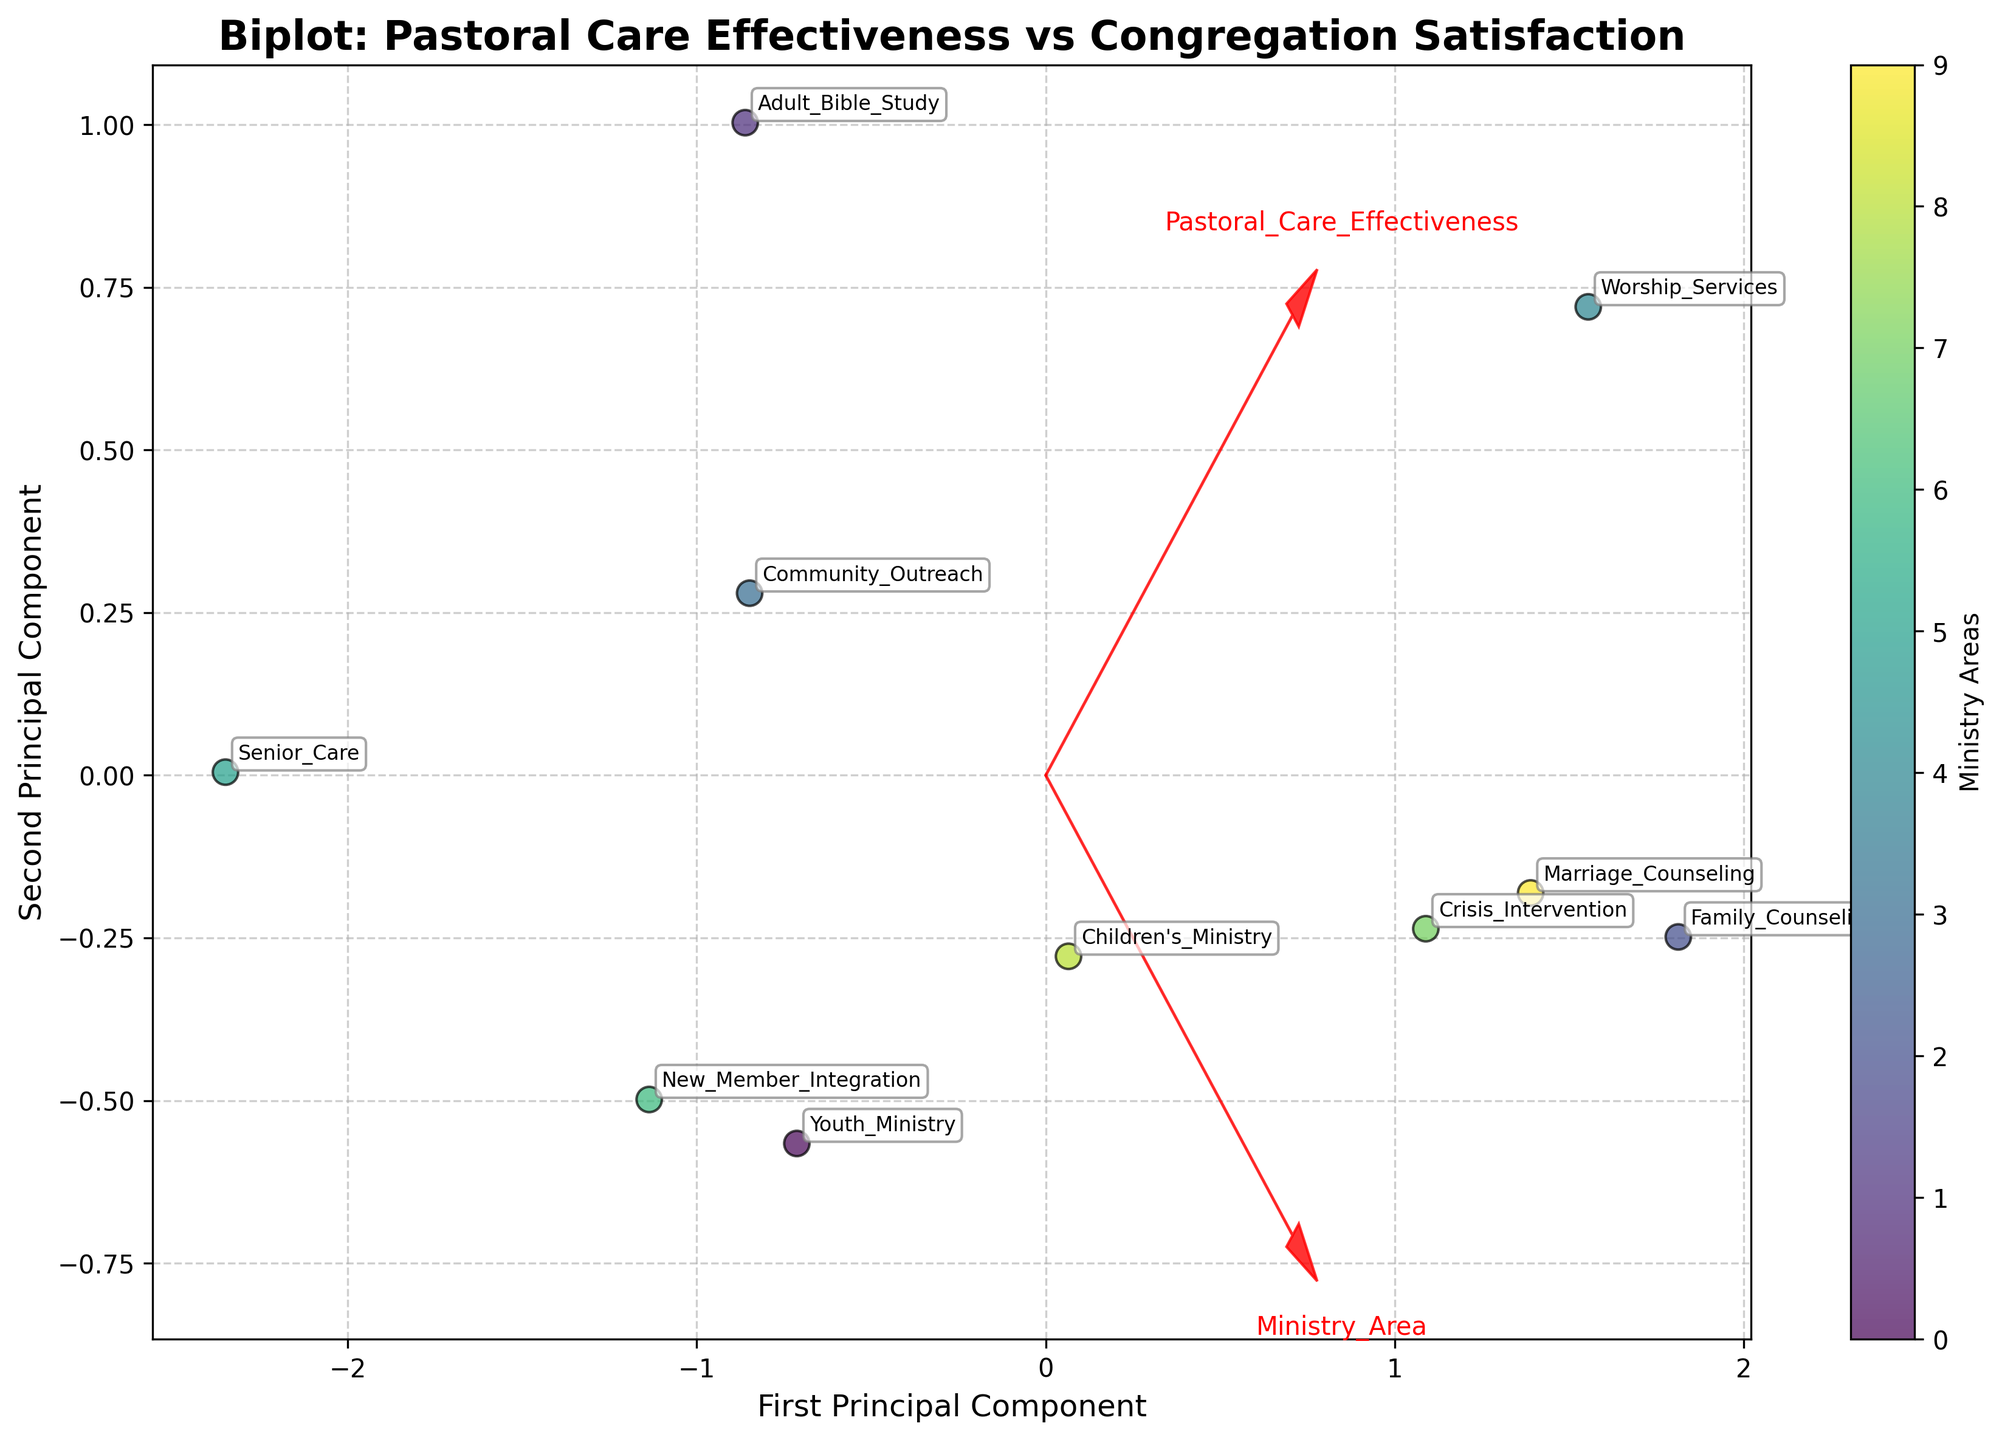What is the title of the figure? The title is usually found at the top of the figure, summarizing the main insight or purpose of the visualization.
Answer: Biplot: Pastoral Care Effectiveness vs Congregation Satisfaction How many ministry areas are represented in the biplot? Each data point in the biplot should correspond to a unique ministry area annotated in the plot.
Answer: 10 Which ministry area is closest to the origin point (0,0) on the biplot? By identifying the point closest to the (0,0) coordinates on the biplot, we can find the ministry area labeled at that location.
Answer: Senior Care Which ministry area has the highest value on the second principal component axis? The second principal component axis runs vertically. Identify the point at the highest vertical position and read its labeled ministry area.
Answer: Worship Services Which two ministry areas are the most similar in terms of pastoral care effectiveness and congregation satisfaction? Look for the two data points that are nearest to each other on the biplot, reflecting similar values for the variables.
Answer: Family Counseling and Marriage Counseling How do the arrows representing pastoral care effectiveness and congregation satisfaction appear on the plot? The arrows are the feature vectors that indicate the direction of the original variables in the principal component space. Describe their direction and length.
Answer: They are directed away from the origin, each indicating the direction and magnitude of the respective variable Which ministry area has a higher combination of pastoral care effectiveness and congregation satisfaction: Youth Ministry or Children's Ministry? Compare the position of Youth Ministry and Children's Ministry points. The one further in the positive direction along both principal component axes has the higher combined value.
Answer: Children's Ministry What is the main distinction between Worship Services and Senior Care in this biplot? Identify the position of both ministry areas on the plot and compare their relative distances along both the principal component axes.
Answer: Worship Services has much higher values for both components compared to Senior Care If a ministry area is highly effective in pastoral care but less satisfactory to the congregation, how would its position look on the biplot? Identify where a point would lie if it had a high value along the direction of the pastoral care effectiveness arrow, but a lower or minimal value along the congregation satisfaction direction.
Answer: It would lie far along the pastoral care effectiveness vector but close to the origin along the congregation satisfaction vector Which ministry area is the most distinct from Community Outreach in terms of the first and second principal components? Look for the ministry area point that is the furthest from Community Outreach on both principal component axes, indicating distinctiveness.
Answer: Senior Care 